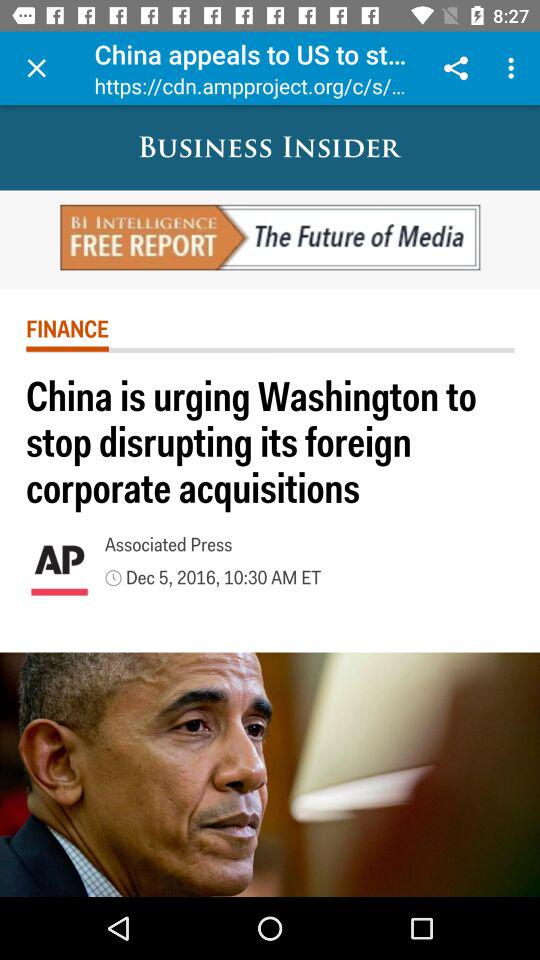When was this article published? The article was published on December 5, 2016 at 10:30 AM ET. 